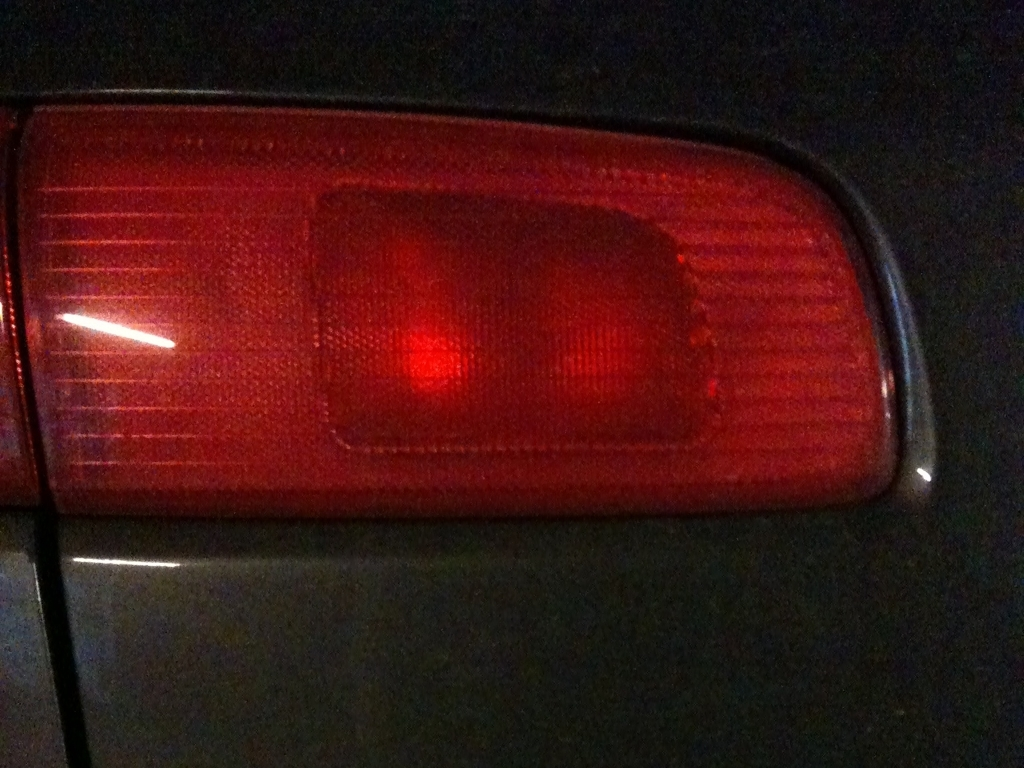Is the composition of the image good? The composition of the image is fairly straightforward, focusing solely on the tail light of a vehicle. It has a clear subject, but lacks context and artistic elements that typically contribute to a 'good' composition. However, it can be considered effective for a functional or descriptive purpose. 